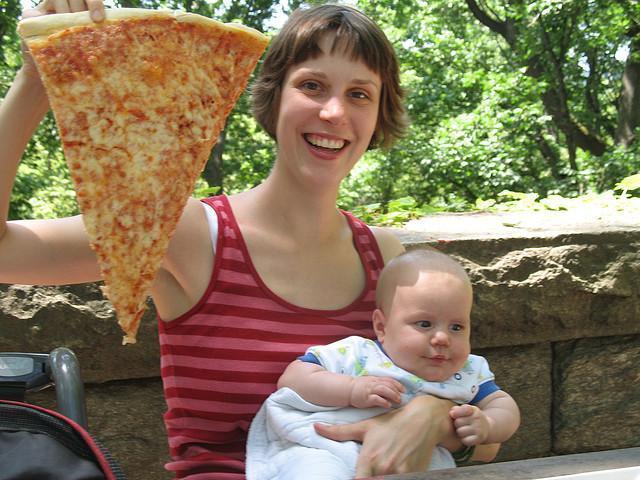How many women are there?
Give a very brief answer. 1. How many bracelets is the woman on the right wearing?
Give a very brief answer. 0. How many people can you see?
Give a very brief answer. 2. How many pizzas are there?
Give a very brief answer. 1. How many blue frosted donuts can you count?
Give a very brief answer. 0. 